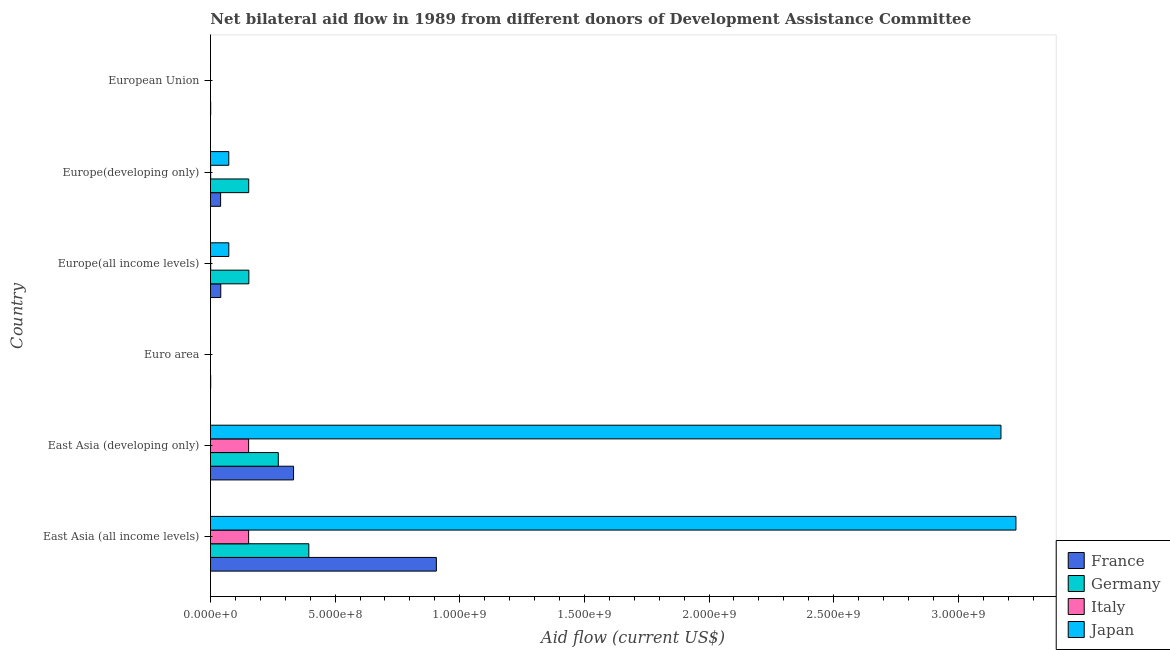Are the number of bars on each tick of the Y-axis equal?
Keep it short and to the point. No. How many bars are there on the 6th tick from the bottom?
Give a very brief answer. 2. What is the label of the 5th group of bars from the top?
Give a very brief answer. East Asia (developing only). What is the amount of aid given by japan in East Asia (developing only)?
Offer a terse response. 3.17e+09. Across all countries, what is the maximum amount of aid given by germany?
Provide a succinct answer. 3.95e+08. Across all countries, what is the minimum amount of aid given by france?
Keep it short and to the point. 8.60e+05. In which country was the amount of aid given by italy maximum?
Ensure brevity in your answer.  East Asia (all income levels). What is the total amount of aid given by germany in the graph?
Keep it short and to the point. 9.74e+08. What is the difference between the amount of aid given by france in Euro area and that in Europe(developing only)?
Your answer should be compact. -3.99e+07. What is the difference between the amount of aid given by italy in Euro area and the amount of aid given by germany in East Asia (all income levels)?
Ensure brevity in your answer.  -3.95e+08. What is the average amount of aid given by germany per country?
Your response must be concise. 1.62e+08. What is the difference between the amount of aid given by germany and amount of aid given by france in Europe(all income levels)?
Your answer should be compact. 1.13e+08. What is the ratio of the amount of aid given by france in Euro area to that in Europe(developing only)?
Provide a short and direct response. 0.02. Is the amount of aid given by germany in East Asia (all income levels) less than that in Europe(all income levels)?
Offer a terse response. No. Is the difference between the amount of aid given by germany in East Asia (all income levels) and Europe(all income levels) greater than the difference between the amount of aid given by france in East Asia (all income levels) and Europe(all income levels)?
Keep it short and to the point. No. What is the difference between the highest and the second highest amount of aid given by japan?
Your response must be concise. 6.00e+07. What is the difference between the highest and the lowest amount of aid given by japan?
Keep it short and to the point. 3.23e+09. In how many countries, is the amount of aid given by japan greater than the average amount of aid given by japan taken over all countries?
Your response must be concise. 2. Is it the case that in every country, the sum of the amount of aid given by italy and amount of aid given by france is greater than the sum of amount of aid given by germany and amount of aid given by japan?
Keep it short and to the point. No. Is it the case that in every country, the sum of the amount of aid given by france and amount of aid given by germany is greater than the amount of aid given by italy?
Ensure brevity in your answer.  Yes. How many bars are there?
Provide a short and direct response. 20. Are all the bars in the graph horizontal?
Give a very brief answer. Yes. What is the difference between two consecutive major ticks on the X-axis?
Make the answer very short. 5.00e+08. Are the values on the major ticks of X-axis written in scientific E-notation?
Your answer should be very brief. Yes. Does the graph contain any zero values?
Your answer should be very brief. Yes. What is the title of the graph?
Provide a succinct answer. Net bilateral aid flow in 1989 from different donors of Development Assistance Committee. What is the label or title of the X-axis?
Make the answer very short. Aid flow (current US$). What is the Aid flow (current US$) in France in East Asia (all income levels)?
Provide a short and direct response. 9.06e+08. What is the Aid flow (current US$) in Germany in East Asia (all income levels)?
Your response must be concise. 3.95e+08. What is the Aid flow (current US$) of Italy in East Asia (all income levels)?
Your answer should be very brief. 1.53e+08. What is the Aid flow (current US$) in Japan in East Asia (all income levels)?
Provide a short and direct response. 3.23e+09. What is the Aid flow (current US$) in France in East Asia (developing only)?
Provide a short and direct response. 3.33e+08. What is the Aid flow (current US$) in Germany in East Asia (developing only)?
Ensure brevity in your answer.  2.72e+08. What is the Aid flow (current US$) of Italy in East Asia (developing only)?
Offer a terse response. 1.53e+08. What is the Aid flow (current US$) in Japan in East Asia (developing only)?
Your answer should be compact. 3.17e+09. What is the Aid flow (current US$) of France in Euro area?
Keep it short and to the point. 8.60e+05. What is the Aid flow (current US$) of Italy in Euro area?
Your response must be concise. 0. What is the Aid flow (current US$) of Japan in Euro area?
Offer a very short reply. 1.70e+05. What is the Aid flow (current US$) in France in Europe(all income levels)?
Provide a succinct answer. 4.13e+07. What is the Aid flow (current US$) in Germany in Europe(all income levels)?
Provide a short and direct response. 1.54e+08. What is the Aid flow (current US$) in Italy in Europe(all income levels)?
Provide a succinct answer. 8.00e+05. What is the Aid flow (current US$) in Japan in Europe(all income levels)?
Offer a terse response. 7.36e+07. What is the Aid flow (current US$) in France in Europe(developing only)?
Make the answer very short. 4.07e+07. What is the Aid flow (current US$) in Germany in Europe(developing only)?
Make the answer very short. 1.53e+08. What is the Aid flow (current US$) of Italy in Europe(developing only)?
Provide a short and direct response. 7.90e+05. What is the Aid flow (current US$) of Japan in Europe(developing only)?
Make the answer very short. 7.34e+07. What is the Aid flow (current US$) of France in European Union?
Make the answer very short. 8.60e+05. What is the Aid flow (current US$) of Germany in European Union?
Keep it short and to the point. 0. Across all countries, what is the maximum Aid flow (current US$) in France?
Make the answer very short. 9.06e+08. Across all countries, what is the maximum Aid flow (current US$) of Germany?
Offer a very short reply. 3.95e+08. Across all countries, what is the maximum Aid flow (current US$) of Italy?
Give a very brief answer. 1.53e+08. Across all countries, what is the maximum Aid flow (current US$) in Japan?
Offer a terse response. 3.23e+09. Across all countries, what is the minimum Aid flow (current US$) of France?
Ensure brevity in your answer.  8.60e+05. Across all countries, what is the minimum Aid flow (current US$) in Italy?
Provide a succinct answer. 0. What is the total Aid flow (current US$) of France in the graph?
Provide a succinct answer. 1.32e+09. What is the total Aid flow (current US$) in Germany in the graph?
Offer a very short reply. 9.74e+08. What is the total Aid flow (current US$) in Italy in the graph?
Give a very brief answer. 3.08e+08. What is the total Aid flow (current US$) of Japan in the graph?
Offer a very short reply. 6.55e+09. What is the difference between the Aid flow (current US$) in France in East Asia (all income levels) and that in East Asia (developing only)?
Keep it short and to the point. 5.73e+08. What is the difference between the Aid flow (current US$) in Germany in East Asia (all income levels) and that in East Asia (developing only)?
Give a very brief answer. 1.22e+08. What is the difference between the Aid flow (current US$) of Japan in East Asia (all income levels) and that in East Asia (developing only)?
Ensure brevity in your answer.  6.00e+07. What is the difference between the Aid flow (current US$) of France in East Asia (all income levels) and that in Euro area?
Provide a short and direct response. 9.05e+08. What is the difference between the Aid flow (current US$) of Japan in East Asia (all income levels) and that in Euro area?
Offer a very short reply. 3.23e+09. What is the difference between the Aid flow (current US$) of France in East Asia (all income levels) and that in Europe(all income levels)?
Offer a terse response. 8.65e+08. What is the difference between the Aid flow (current US$) of Germany in East Asia (all income levels) and that in Europe(all income levels)?
Keep it short and to the point. 2.41e+08. What is the difference between the Aid flow (current US$) of Italy in East Asia (all income levels) and that in Europe(all income levels)?
Ensure brevity in your answer.  1.52e+08. What is the difference between the Aid flow (current US$) in Japan in East Asia (all income levels) and that in Europe(all income levels)?
Keep it short and to the point. 3.16e+09. What is the difference between the Aid flow (current US$) in France in East Asia (all income levels) and that in Europe(developing only)?
Provide a short and direct response. 8.65e+08. What is the difference between the Aid flow (current US$) in Germany in East Asia (all income levels) and that in Europe(developing only)?
Ensure brevity in your answer.  2.41e+08. What is the difference between the Aid flow (current US$) in Italy in East Asia (all income levels) and that in Europe(developing only)?
Make the answer very short. 1.52e+08. What is the difference between the Aid flow (current US$) of Japan in East Asia (all income levels) and that in Europe(developing only)?
Provide a succinct answer. 3.16e+09. What is the difference between the Aid flow (current US$) of France in East Asia (all income levels) and that in European Union?
Your answer should be very brief. 9.05e+08. What is the difference between the Aid flow (current US$) in Japan in East Asia (all income levels) and that in European Union?
Your answer should be very brief. 3.23e+09. What is the difference between the Aid flow (current US$) of France in East Asia (developing only) and that in Euro area?
Provide a short and direct response. 3.32e+08. What is the difference between the Aid flow (current US$) in Japan in East Asia (developing only) and that in Euro area?
Your answer should be very brief. 3.17e+09. What is the difference between the Aid flow (current US$) of France in East Asia (developing only) and that in Europe(all income levels)?
Give a very brief answer. 2.92e+08. What is the difference between the Aid flow (current US$) of Germany in East Asia (developing only) and that in Europe(all income levels)?
Provide a succinct answer. 1.18e+08. What is the difference between the Aid flow (current US$) in Italy in East Asia (developing only) and that in Europe(all income levels)?
Keep it short and to the point. 1.52e+08. What is the difference between the Aid flow (current US$) of Japan in East Asia (developing only) and that in Europe(all income levels)?
Make the answer very short. 3.10e+09. What is the difference between the Aid flow (current US$) in France in East Asia (developing only) and that in Europe(developing only)?
Make the answer very short. 2.93e+08. What is the difference between the Aid flow (current US$) of Germany in East Asia (developing only) and that in Europe(developing only)?
Your answer should be compact. 1.19e+08. What is the difference between the Aid flow (current US$) in Italy in East Asia (developing only) and that in Europe(developing only)?
Provide a succinct answer. 1.52e+08. What is the difference between the Aid flow (current US$) in Japan in East Asia (developing only) and that in Europe(developing only)?
Offer a terse response. 3.10e+09. What is the difference between the Aid flow (current US$) in France in East Asia (developing only) and that in European Union?
Offer a terse response. 3.32e+08. What is the difference between the Aid flow (current US$) in Japan in East Asia (developing only) and that in European Union?
Offer a very short reply. 3.17e+09. What is the difference between the Aid flow (current US$) of France in Euro area and that in Europe(all income levels)?
Your answer should be compact. -4.04e+07. What is the difference between the Aid flow (current US$) of Japan in Euro area and that in Europe(all income levels)?
Make the answer very short. -7.34e+07. What is the difference between the Aid flow (current US$) in France in Euro area and that in Europe(developing only)?
Offer a very short reply. -3.99e+07. What is the difference between the Aid flow (current US$) in Japan in Euro area and that in Europe(developing only)?
Your response must be concise. -7.33e+07. What is the difference between the Aid flow (current US$) of France in Euro area and that in European Union?
Your response must be concise. 0. What is the difference between the Aid flow (current US$) of Japan in Euro area and that in European Union?
Your response must be concise. 0. What is the difference between the Aid flow (current US$) in France in Europe(all income levels) and that in Europe(developing only)?
Give a very brief answer. 5.60e+05. What is the difference between the Aid flow (current US$) in Germany in Europe(all income levels) and that in Europe(developing only)?
Provide a succinct answer. 5.20e+05. What is the difference between the Aid flow (current US$) of Italy in Europe(all income levels) and that in Europe(developing only)?
Ensure brevity in your answer.  10000. What is the difference between the Aid flow (current US$) in Japan in Europe(all income levels) and that in Europe(developing only)?
Provide a short and direct response. 1.10e+05. What is the difference between the Aid flow (current US$) in France in Europe(all income levels) and that in European Union?
Provide a succinct answer. 4.04e+07. What is the difference between the Aid flow (current US$) in Japan in Europe(all income levels) and that in European Union?
Give a very brief answer. 7.34e+07. What is the difference between the Aid flow (current US$) of France in Europe(developing only) and that in European Union?
Provide a short and direct response. 3.99e+07. What is the difference between the Aid flow (current US$) in Japan in Europe(developing only) and that in European Union?
Keep it short and to the point. 7.33e+07. What is the difference between the Aid flow (current US$) of France in East Asia (all income levels) and the Aid flow (current US$) of Germany in East Asia (developing only)?
Ensure brevity in your answer.  6.34e+08. What is the difference between the Aid flow (current US$) of France in East Asia (all income levels) and the Aid flow (current US$) of Italy in East Asia (developing only)?
Your answer should be compact. 7.53e+08. What is the difference between the Aid flow (current US$) of France in East Asia (all income levels) and the Aid flow (current US$) of Japan in East Asia (developing only)?
Ensure brevity in your answer.  -2.26e+09. What is the difference between the Aid flow (current US$) of Germany in East Asia (all income levels) and the Aid flow (current US$) of Italy in East Asia (developing only)?
Your answer should be compact. 2.41e+08. What is the difference between the Aid flow (current US$) in Germany in East Asia (all income levels) and the Aid flow (current US$) in Japan in East Asia (developing only)?
Make the answer very short. -2.78e+09. What is the difference between the Aid flow (current US$) of Italy in East Asia (all income levels) and the Aid flow (current US$) of Japan in East Asia (developing only)?
Your answer should be compact. -3.02e+09. What is the difference between the Aid flow (current US$) of France in East Asia (all income levels) and the Aid flow (current US$) of Japan in Euro area?
Offer a terse response. 9.06e+08. What is the difference between the Aid flow (current US$) of Germany in East Asia (all income levels) and the Aid flow (current US$) of Japan in Euro area?
Ensure brevity in your answer.  3.94e+08. What is the difference between the Aid flow (current US$) of Italy in East Asia (all income levels) and the Aid flow (current US$) of Japan in Euro area?
Offer a very short reply. 1.53e+08. What is the difference between the Aid flow (current US$) in France in East Asia (all income levels) and the Aid flow (current US$) in Germany in Europe(all income levels)?
Make the answer very short. 7.52e+08. What is the difference between the Aid flow (current US$) of France in East Asia (all income levels) and the Aid flow (current US$) of Italy in Europe(all income levels)?
Ensure brevity in your answer.  9.05e+08. What is the difference between the Aid flow (current US$) in France in East Asia (all income levels) and the Aid flow (current US$) in Japan in Europe(all income levels)?
Make the answer very short. 8.33e+08. What is the difference between the Aid flow (current US$) in Germany in East Asia (all income levels) and the Aid flow (current US$) in Italy in Europe(all income levels)?
Make the answer very short. 3.94e+08. What is the difference between the Aid flow (current US$) in Germany in East Asia (all income levels) and the Aid flow (current US$) in Japan in Europe(all income levels)?
Provide a short and direct response. 3.21e+08. What is the difference between the Aid flow (current US$) in Italy in East Asia (all income levels) and the Aid flow (current US$) in Japan in Europe(all income levels)?
Your response must be concise. 7.95e+07. What is the difference between the Aid flow (current US$) of France in East Asia (all income levels) and the Aid flow (current US$) of Germany in Europe(developing only)?
Your response must be concise. 7.53e+08. What is the difference between the Aid flow (current US$) in France in East Asia (all income levels) and the Aid flow (current US$) in Italy in Europe(developing only)?
Your answer should be compact. 9.05e+08. What is the difference between the Aid flow (current US$) in France in East Asia (all income levels) and the Aid flow (current US$) in Japan in Europe(developing only)?
Your answer should be compact. 8.33e+08. What is the difference between the Aid flow (current US$) of Germany in East Asia (all income levels) and the Aid flow (current US$) of Italy in Europe(developing only)?
Offer a very short reply. 3.94e+08. What is the difference between the Aid flow (current US$) in Germany in East Asia (all income levels) and the Aid flow (current US$) in Japan in Europe(developing only)?
Offer a terse response. 3.21e+08. What is the difference between the Aid flow (current US$) in Italy in East Asia (all income levels) and the Aid flow (current US$) in Japan in Europe(developing only)?
Offer a terse response. 7.96e+07. What is the difference between the Aid flow (current US$) of France in East Asia (all income levels) and the Aid flow (current US$) of Japan in European Union?
Give a very brief answer. 9.06e+08. What is the difference between the Aid flow (current US$) in Germany in East Asia (all income levels) and the Aid flow (current US$) in Japan in European Union?
Ensure brevity in your answer.  3.94e+08. What is the difference between the Aid flow (current US$) of Italy in East Asia (all income levels) and the Aid flow (current US$) of Japan in European Union?
Provide a short and direct response. 1.53e+08. What is the difference between the Aid flow (current US$) in France in East Asia (developing only) and the Aid flow (current US$) in Japan in Euro area?
Offer a terse response. 3.33e+08. What is the difference between the Aid flow (current US$) in Germany in East Asia (developing only) and the Aid flow (current US$) in Japan in Euro area?
Keep it short and to the point. 2.72e+08. What is the difference between the Aid flow (current US$) in Italy in East Asia (developing only) and the Aid flow (current US$) in Japan in Euro area?
Keep it short and to the point. 1.53e+08. What is the difference between the Aid flow (current US$) of France in East Asia (developing only) and the Aid flow (current US$) of Germany in Europe(all income levels)?
Offer a very short reply. 1.79e+08. What is the difference between the Aid flow (current US$) in France in East Asia (developing only) and the Aid flow (current US$) in Italy in Europe(all income levels)?
Keep it short and to the point. 3.32e+08. What is the difference between the Aid flow (current US$) in France in East Asia (developing only) and the Aid flow (current US$) in Japan in Europe(all income levels)?
Give a very brief answer. 2.60e+08. What is the difference between the Aid flow (current US$) in Germany in East Asia (developing only) and the Aid flow (current US$) in Italy in Europe(all income levels)?
Provide a succinct answer. 2.71e+08. What is the difference between the Aid flow (current US$) in Germany in East Asia (developing only) and the Aid flow (current US$) in Japan in Europe(all income levels)?
Keep it short and to the point. 1.99e+08. What is the difference between the Aid flow (current US$) in Italy in East Asia (developing only) and the Aid flow (current US$) in Japan in Europe(all income levels)?
Provide a succinct answer. 7.95e+07. What is the difference between the Aid flow (current US$) in France in East Asia (developing only) and the Aid flow (current US$) in Germany in Europe(developing only)?
Provide a succinct answer. 1.80e+08. What is the difference between the Aid flow (current US$) of France in East Asia (developing only) and the Aid flow (current US$) of Italy in Europe(developing only)?
Your answer should be very brief. 3.32e+08. What is the difference between the Aid flow (current US$) of France in East Asia (developing only) and the Aid flow (current US$) of Japan in Europe(developing only)?
Make the answer very short. 2.60e+08. What is the difference between the Aid flow (current US$) of Germany in East Asia (developing only) and the Aid flow (current US$) of Italy in Europe(developing only)?
Provide a short and direct response. 2.71e+08. What is the difference between the Aid flow (current US$) of Germany in East Asia (developing only) and the Aid flow (current US$) of Japan in Europe(developing only)?
Provide a succinct answer. 1.99e+08. What is the difference between the Aid flow (current US$) of Italy in East Asia (developing only) and the Aid flow (current US$) of Japan in Europe(developing only)?
Keep it short and to the point. 7.96e+07. What is the difference between the Aid flow (current US$) in France in East Asia (developing only) and the Aid flow (current US$) in Japan in European Union?
Give a very brief answer. 3.33e+08. What is the difference between the Aid flow (current US$) in Germany in East Asia (developing only) and the Aid flow (current US$) in Japan in European Union?
Provide a succinct answer. 2.72e+08. What is the difference between the Aid flow (current US$) of Italy in East Asia (developing only) and the Aid flow (current US$) of Japan in European Union?
Your answer should be very brief. 1.53e+08. What is the difference between the Aid flow (current US$) in France in Euro area and the Aid flow (current US$) in Germany in Europe(all income levels)?
Make the answer very short. -1.53e+08. What is the difference between the Aid flow (current US$) of France in Euro area and the Aid flow (current US$) of Italy in Europe(all income levels)?
Provide a short and direct response. 6.00e+04. What is the difference between the Aid flow (current US$) in France in Euro area and the Aid flow (current US$) in Japan in Europe(all income levels)?
Keep it short and to the point. -7.27e+07. What is the difference between the Aid flow (current US$) in France in Euro area and the Aid flow (current US$) in Germany in Europe(developing only)?
Ensure brevity in your answer.  -1.53e+08. What is the difference between the Aid flow (current US$) of France in Euro area and the Aid flow (current US$) of Italy in Europe(developing only)?
Offer a very short reply. 7.00e+04. What is the difference between the Aid flow (current US$) in France in Euro area and the Aid flow (current US$) in Japan in Europe(developing only)?
Make the answer very short. -7.26e+07. What is the difference between the Aid flow (current US$) of France in Euro area and the Aid flow (current US$) of Japan in European Union?
Offer a very short reply. 6.90e+05. What is the difference between the Aid flow (current US$) of France in Europe(all income levels) and the Aid flow (current US$) of Germany in Europe(developing only)?
Your answer should be very brief. -1.12e+08. What is the difference between the Aid flow (current US$) in France in Europe(all income levels) and the Aid flow (current US$) in Italy in Europe(developing only)?
Your answer should be very brief. 4.05e+07. What is the difference between the Aid flow (current US$) in France in Europe(all income levels) and the Aid flow (current US$) in Japan in Europe(developing only)?
Your answer should be very brief. -3.22e+07. What is the difference between the Aid flow (current US$) of Germany in Europe(all income levels) and the Aid flow (current US$) of Italy in Europe(developing only)?
Provide a succinct answer. 1.53e+08. What is the difference between the Aid flow (current US$) in Germany in Europe(all income levels) and the Aid flow (current US$) in Japan in Europe(developing only)?
Your answer should be very brief. 8.05e+07. What is the difference between the Aid flow (current US$) in Italy in Europe(all income levels) and the Aid flow (current US$) in Japan in Europe(developing only)?
Offer a terse response. -7.26e+07. What is the difference between the Aid flow (current US$) in France in Europe(all income levels) and the Aid flow (current US$) in Japan in European Union?
Keep it short and to the point. 4.11e+07. What is the difference between the Aid flow (current US$) of Germany in Europe(all income levels) and the Aid flow (current US$) of Japan in European Union?
Give a very brief answer. 1.54e+08. What is the difference between the Aid flow (current US$) of Italy in Europe(all income levels) and the Aid flow (current US$) of Japan in European Union?
Your response must be concise. 6.30e+05. What is the difference between the Aid flow (current US$) in France in Europe(developing only) and the Aid flow (current US$) in Japan in European Union?
Your answer should be very brief. 4.06e+07. What is the difference between the Aid flow (current US$) of Germany in Europe(developing only) and the Aid flow (current US$) of Japan in European Union?
Your answer should be compact. 1.53e+08. What is the difference between the Aid flow (current US$) of Italy in Europe(developing only) and the Aid flow (current US$) of Japan in European Union?
Give a very brief answer. 6.20e+05. What is the average Aid flow (current US$) in France per country?
Make the answer very short. 2.21e+08. What is the average Aid flow (current US$) of Germany per country?
Your answer should be compact. 1.62e+08. What is the average Aid flow (current US$) in Italy per country?
Offer a terse response. 5.13e+07. What is the average Aid flow (current US$) in Japan per country?
Your answer should be compact. 1.09e+09. What is the difference between the Aid flow (current US$) of France and Aid flow (current US$) of Germany in East Asia (all income levels)?
Keep it short and to the point. 5.12e+08. What is the difference between the Aid flow (current US$) of France and Aid flow (current US$) of Italy in East Asia (all income levels)?
Your answer should be very brief. 7.53e+08. What is the difference between the Aid flow (current US$) of France and Aid flow (current US$) of Japan in East Asia (all income levels)?
Your response must be concise. -2.32e+09. What is the difference between the Aid flow (current US$) of Germany and Aid flow (current US$) of Italy in East Asia (all income levels)?
Offer a terse response. 2.41e+08. What is the difference between the Aid flow (current US$) of Germany and Aid flow (current US$) of Japan in East Asia (all income levels)?
Provide a short and direct response. -2.84e+09. What is the difference between the Aid flow (current US$) in Italy and Aid flow (current US$) in Japan in East Asia (all income levels)?
Keep it short and to the point. -3.08e+09. What is the difference between the Aid flow (current US$) in France and Aid flow (current US$) in Germany in East Asia (developing only)?
Keep it short and to the point. 6.12e+07. What is the difference between the Aid flow (current US$) in France and Aid flow (current US$) in Italy in East Asia (developing only)?
Ensure brevity in your answer.  1.80e+08. What is the difference between the Aid flow (current US$) of France and Aid flow (current US$) of Japan in East Asia (developing only)?
Your answer should be compact. -2.84e+09. What is the difference between the Aid flow (current US$) in Germany and Aid flow (current US$) in Italy in East Asia (developing only)?
Your answer should be very brief. 1.19e+08. What is the difference between the Aid flow (current US$) of Germany and Aid flow (current US$) of Japan in East Asia (developing only)?
Your answer should be compact. -2.90e+09. What is the difference between the Aid flow (current US$) of Italy and Aid flow (current US$) of Japan in East Asia (developing only)?
Make the answer very short. -3.02e+09. What is the difference between the Aid flow (current US$) in France and Aid flow (current US$) in Japan in Euro area?
Your response must be concise. 6.90e+05. What is the difference between the Aid flow (current US$) of France and Aid flow (current US$) of Germany in Europe(all income levels)?
Offer a terse response. -1.13e+08. What is the difference between the Aid flow (current US$) of France and Aid flow (current US$) of Italy in Europe(all income levels)?
Give a very brief answer. 4.05e+07. What is the difference between the Aid flow (current US$) in France and Aid flow (current US$) in Japan in Europe(all income levels)?
Provide a succinct answer. -3.23e+07. What is the difference between the Aid flow (current US$) in Germany and Aid flow (current US$) in Italy in Europe(all income levels)?
Keep it short and to the point. 1.53e+08. What is the difference between the Aid flow (current US$) in Germany and Aid flow (current US$) in Japan in Europe(all income levels)?
Provide a short and direct response. 8.04e+07. What is the difference between the Aid flow (current US$) of Italy and Aid flow (current US$) of Japan in Europe(all income levels)?
Give a very brief answer. -7.28e+07. What is the difference between the Aid flow (current US$) in France and Aid flow (current US$) in Germany in Europe(developing only)?
Keep it short and to the point. -1.13e+08. What is the difference between the Aid flow (current US$) of France and Aid flow (current US$) of Italy in Europe(developing only)?
Offer a very short reply. 3.99e+07. What is the difference between the Aid flow (current US$) of France and Aid flow (current US$) of Japan in Europe(developing only)?
Keep it short and to the point. -3.27e+07. What is the difference between the Aid flow (current US$) in Germany and Aid flow (current US$) in Italy in Europe(developing only)?
Provide a short and direct response. 1.53e+08. What is the difference between the Aid flow (current US$) in Germany and Aid flow (current US$) in Japan in Europe(developing only)?
Your response must be concise. 8.00e+07. What is the difference between the Aid flow (current US$) of Italy and Aid flow (current US$) of Japan in Europe(developing only)?
Offer a terse response. -7.27e+07. What is the difference between the Aid flow (current US$) of France and Aid flow (current US$) of Japan in European Union?
Offer a very short reply. 6.90e+05. What is the ratio of the Aid flow (current US$) in France in East Asia (all income levels) to that in East Asia (developing only)?
Give a very brief answer. 2.72. What is the ratio of the Aid flow (current US$) in Germany in East Asia (all income levels) to that in East Asia (developing only)?
Your answer should be very brief. 1.45. What is the ratio of the Aid flow (current US$) in Japan in East Asia (all income levels) to that in East Asia (developing only)?
Keep it short and to the point. 1.02. What is the ratio of the Aid flow (current US$) in France in East Asia (all income levels) to that in Euro area?
Your answer should be compact. 1053.64. What is the ratio of the Aid flow (current US$) of Japan in East Asia (all income levels) to that in Euro area?
Provide a short and direct response. 1.90e+04. What is the ratio of the Aid flow (current US$) of France in East Asia (all income levels) to that in Europe(all income levels)?
Offer a terse response. 21.94. What is the ratio of the Aid flow (current US$) of Germany in East Asia (all income levels) to that in Europe(all income levels)?
Provide a short and direct response. 2.56. What is the ratio of the Aid flow (current US$) of Italy in East Asia (all income levels) to that in Europe(all income levels)?
Make the answer very short. 191.34. What is the ratio of the Aid flow (current US$) in Japan in East Asia (all income levels) to that in Europe(all income levels)?
Offer a very short reply. 43.92. What is the ratio of the Aid flow (current US$) of France in East Asia (all income levels) to that in Europe(developing only)?
Keep it short and to the point. 22.24. What is the ratio of the Aid flow (current US$) of Germany in East Asia (all income levels) to that in Europe(developing only)?
Keep it short and to the point. 2.57. What is the ratio of the Aid flow (current US$) in Italy in East Asia (all income levels) to that in Europe(developing only)?
Provide a succinct answer. 193.76. What is the ratio of the Aid flow (current US$) in Japan in East Asia (all income levels) to that in Europe(developing only)?
Offer a very short reply. 43.99. What is the ratio of the Aid flow (current US$) in France in East Asia (all income levels) to that in European Union?
Your response must be concise. 1053.64. What is the ratio of the Aid flow (current US$) of Japan in East Asia (all income levels) to that in European Union?
Provide a short and direct response. 1.90e+04. What is the ratio of the Aid flow (current US$) in France in East Asia (developing only) to that in Euro area?
Make the answer very short. 387.53. What is the ratio of the Aid flow (current US$) of Japan in East Asia (developing only) to that in Euro area?
Provide a succinct answer. 1.87e+04. What is the ratio of the Aid flow (current US$) in France in East Asia (developing only) to that in Europe(all income levels)?
Offer a terse response. 8.07. What is the ratio of the Aid flow (current US$) of Germany in East Asia (developing only) to that in Europe(all income levels)?
Your response must be concise. 1.77. What is the ratio of the Aid flow (current US$) in Italy in East Asia (developing only) to that in Europe(all income levels)?
Offer a very short reply. 191.34. What is the ratio of the Aid flow (current US$) of Japan in East Asia (developing only) to that in Europe(all income levels)?
Keep it short and to the point. 43.11. What is the ratio of the Aid flow (current US$) in France in East Asia (developing only) to that in Europe(developing only)?
Provide a succinct answer. 8.18. What is the ratio of the Aid flow (current US$) in Germany in East Asia (developing only) to that in Europe(developing only)?
Your answer should be compact. 1.77. What is the ratio of the Aid flow (current US$) in Italy in East Asia (developing only) to that in Europe(developing only)?
Ensure brevity in your answer.  193.76. What is the ratio of the Aid flow (current US$) of Japan in East Asia (developing only) to that in Europe(developing only)?
Ensure brevity in your answer.  43.17. What is the ratio of the Aid flow (current US$) in France in East Asia (developing only) to that in European Union?
Provide a succinct answer. 387.53. What is the ratio of the Aid flow (current US$) of Japan in East Asia (developing only) to that in European Union?
Make the answer very short. 1.87e+04. What is the ratio of the Aid flow (current US$) in France in Euro area to that in Europe(all income levels)?
Offer a terse response. 0.02. What is the ratio of the Aid flow (current US$) in Japan in Euro area to that in Europe(all income levels)?
Keep it short and to the point. 0. What is the ratio of the Aid flow (current US$) in France in Euro area to that in Europe(developing only)?
Make the answer very short. 0.02. What is the ratio of the Aid flow (current US$) of Japan in Euro area to that in Europe(developing only)?
Your answer should be very brief. 0. What is the ratio of the Aid flow (current US$) of France in Euro area to that in European Union?
Provide a succinct answer. 1. What is the ratio of the Aid flow (current US$) of Japan in Euro area to that in European Union?
Offer a very short reply. 1. What is the ratio of the Aid flow (current US$) of France in Europe(all income levels) to that in Europe(developing only)?
Your answer should be compact. 1.01. What is the ratio of the Aid flow (current US$) of Italy in Europe(all income levels) to that in Europe(developing only)?
Your answer should be compact. 1.01. What is the ratio of the Aid flow (current US$) in Japan in Europe(all income levels) to that in Europe(developing only)?
Provide a short and direct response. 1. What is the ratio of the Aid flow (current US$) in France in Europe(all income levels) to that in European Union?
Ensure brevity in your answer.  48.02. What is the ratio of the Aid flow (current US$) in Japan in Europe(all income levels) to that in European Union?
Your answer should be compact. 432.71. What is the ratio of the Aid flow (current US$) in France in Europe(developing only) to that in European Union?
Keep it short and to the point. 47.37. What is the ratio of the Aid flow (current US$) of Japan in Europe(developing only) to that in European Union?
Your answer should be compact. 432.06. What is the difference between the highest and the second highest Aid flow (current US$) of France?
Ensure brevity in your answer.  5.73e+08. What is the difference between the highest and the second highest Aid flow (current US$) of Germany?
Offer a terse response. 1.22e+08. What is the difference between the highest and the second highest Aid flow (current US$) of Italy?
Your answer should be very brief. 0. What is the difference between the highest and the second highest Aid flow (current US$) of Japan?
Your response must be concise. 6.00e+07. What is the difference between the highest and the lowest Aid flow (current US$) of France?
Keep it short and to the point. 9.05e+08. What is the difference between the highest and the lowest Aid flow (current US$) in Germany?
Offer a very short reply. 3.95e+08. What is the difference between the highest and the lowest Aid flow (current US$) in Italy?
Make the answer very short. 1.53e+08. What is the difference between the highest and the lowest Aid flow (current US$) in Japan?
Your answer should be very brief. 3.23e+09. 